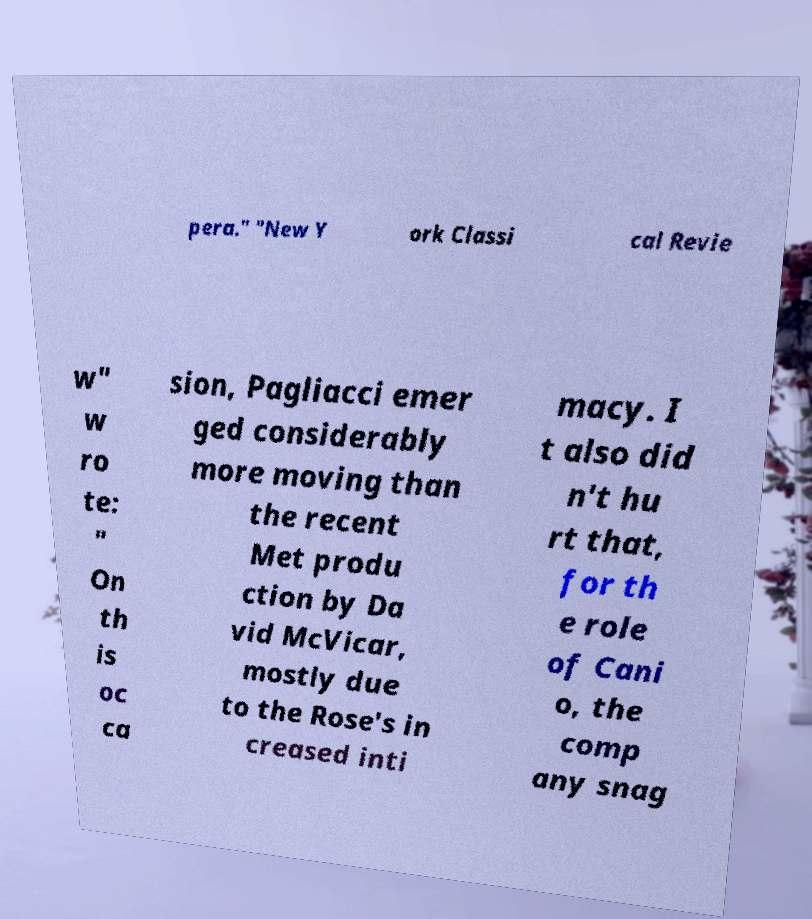There's text embedded in this image that I need extracted. Can you transcribe it verbatim? pera." "New Y ork Classi cal Revie w" w ro te: " On th is oc ca sion, Pagliacci emer ged considerably more moving than the recent Met produ ction by Da vid McVicar, mostly due to the Rose's in creased inti macy. I t also did n't hu rt that, for th e role of Cani o, the comp any snag 